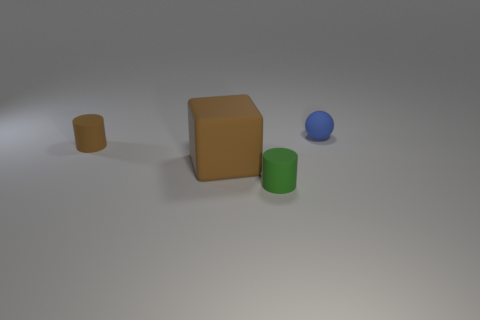Add 3 tiny gray balls. How many objects exist? 7 Subtract all spheres. How many objects are left? 3 Subtract all brown shiny spheres. Subtract all brown rubber objects. How many objects are left? 2 Add 2 green rubber objects. How many green rubber objects are left? 3 Add 2 small cyan matte cubes. How many small cyan matte cubes exist? 2 Subtract 0 cyan cylinders. How many objects are left? 4 